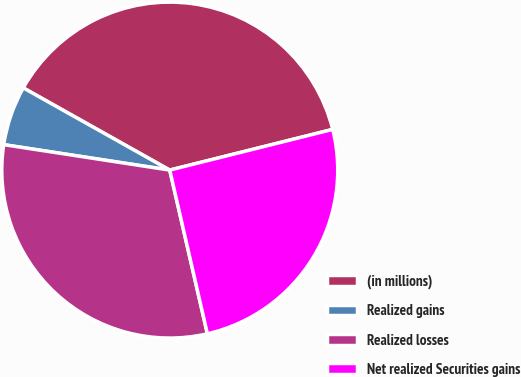Convert chart to OTSL. <chart><loc_0><loc_0><loc_500><loc_500><pie_chart><fcel>(in millions)<fcel>Realized gains<fcel>Realized losses<fcel>Net realized Securities gains<nl><fcel>37.97%<fcel>5.72%<fcel>31.02%<fcel>25.3%<nl></chart> 